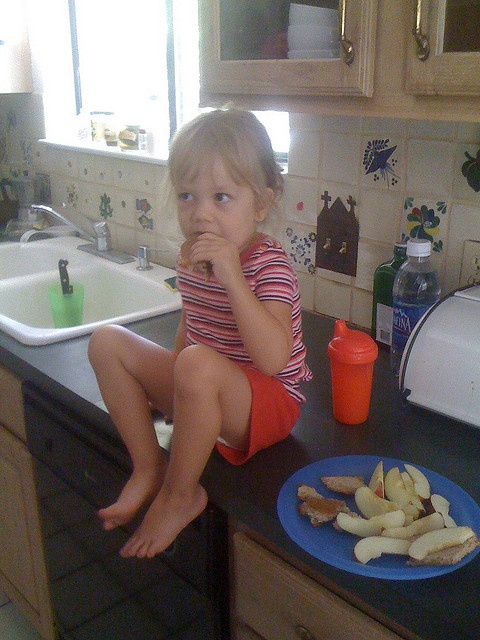Describe the objects in this image and their specific colors. I can see people in white, gray, maroon, and brown tones, sink in white, darkgray, lightgray, and green tones, apple in white, gray, and darkgray tones, cup in white, brown, maroon, and black tones, and bottle in white, gray, navy, black, and darkgray tones in this image. 